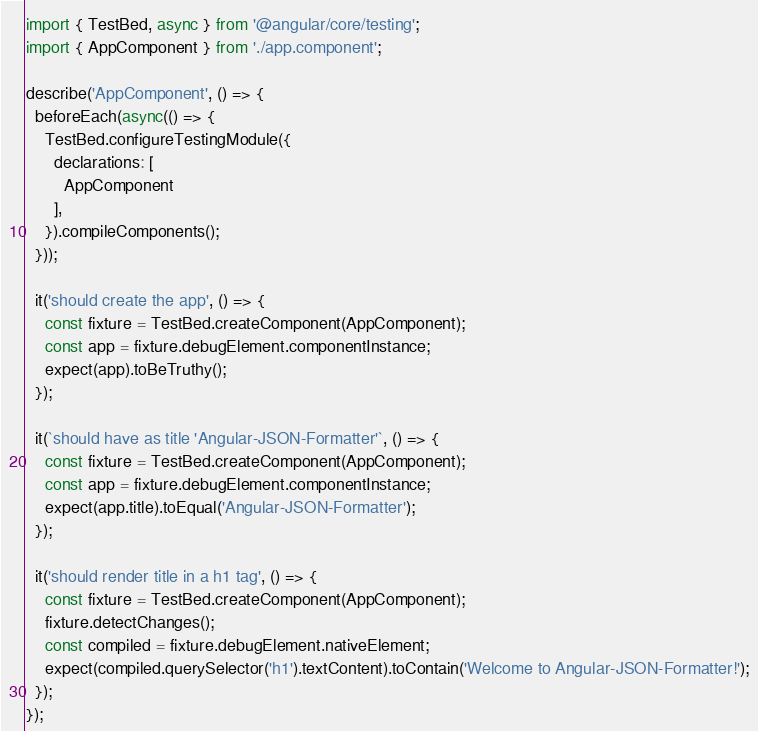<code> <loc_0><loc_0><loc_500><loc_500><_TypeScript_>import { TestBed, async } from '@angular/core/testing';
import { AppComponent } from './app.component';

describe('AppComponent', () => {
  beforeEach(async(() => {
    TestBed.configureTestingModule({
      declarations: [
        AppComponent
      ],
    }).compileComponents();
  }));

  it('should create the app', () => {
    const fixture = TestBed.createComponent(AppComponent);
    const app = fixture.debugElement.componentInstance;
    expect(app).toBeTruthy();
  });

  it(`should have as title 'Angular-JSON-Formatter'`, () => {
    const fixture = TestBed.createComponent(AppComponent);
    const app = fixture.debugElement.componentInstance;
    expect(app.title).toEqual('Angular-JSON-Formatter');
  });

  it('should render title in a h1 tag', () => {
    const fixture = TestBed.createComponent(AppComponent);
    fixture.detectChanges();
    const compiled = fixture.debugElement.nativeElement;
    expect(compiled.querySelector('h1').textContent).toContain('Welcome to Angular-JSON-Formatter!');
  });
});
</code> 